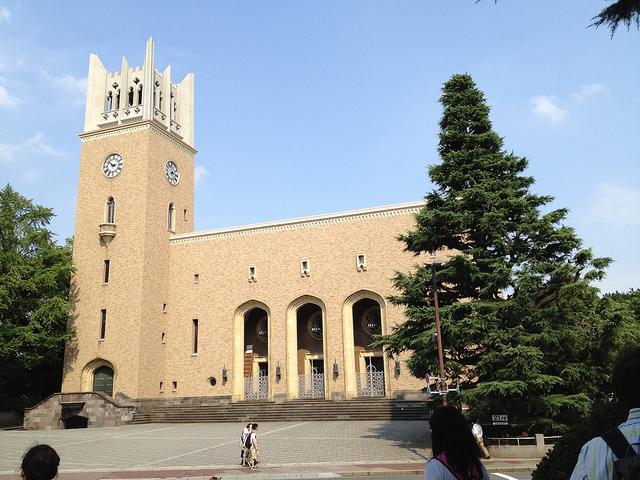How many street poles?
Quick response, please. 1. How many clock faces are on the tower?
Give a very brief answer. 2. Is there a church steeple visible?
Write a very short answer. Yes. What type of tree is in this photo?
Quick response, please. Evergreen. Are the trees bare?
Quick response, please. No. Where is the sun?
Give a very brief answer. Sky. Where can you tell time?
Answer briefly. Clock tower. What culture has influenced this architecture?
Write a very short answer. Roman. Is there a tree in front of the building?
Quick response, please. Yes. How many people are there?
Keep it brief. 5. Do you see any people walking under the clock?
Quick response, please. No. What type of tree is in the picture?
Short answer required. Pine. Is this a stand-alone clock tower?
Be succinct. No. 